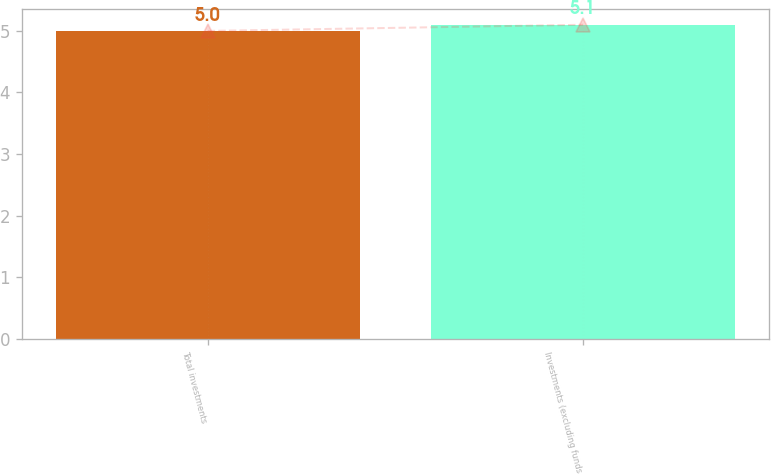<chart> <loc_0><loc_0><loc_500><loc_500><bar_chart><fcel>Total investments<fcel>Investments (excluding funds<nl><fcel>5<fcel>5.1<nl></chart> 